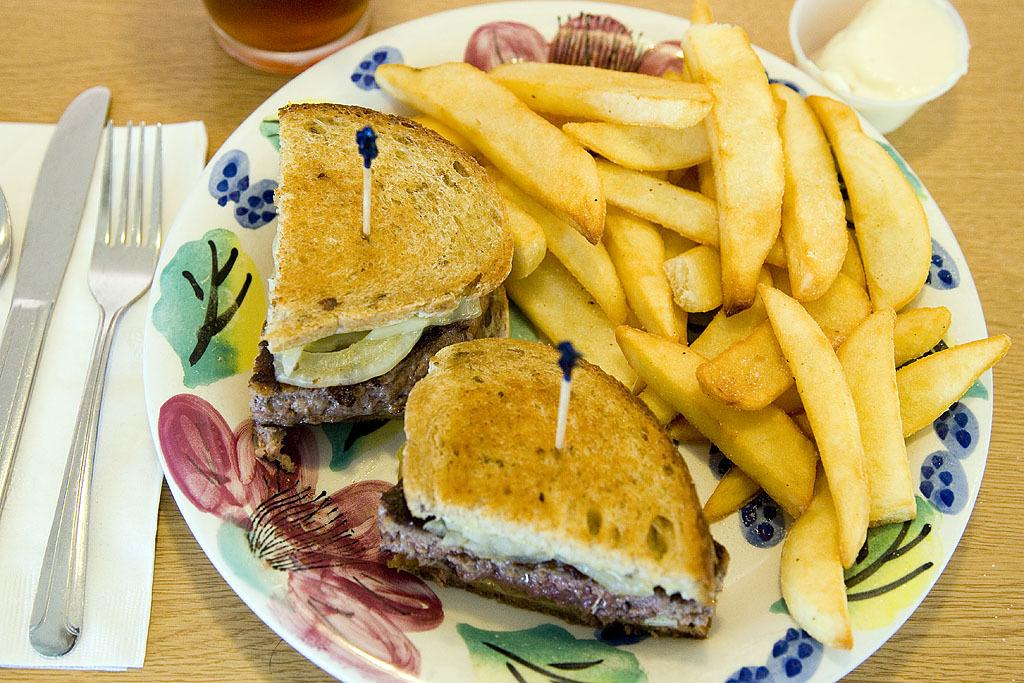What is on the plate that is visible in the image? There is a plate of food in the image. What item can be used for cleaning or wiping in the image? There is a tissue in the image for cleaning or wiping. What utensils are visible in the image? There is a fork, spoons, and a knife visible in the image. What is the surface on which the glasses are placed in the image? The glasses are placed on a wooden table in the image. Where is the giraffe sitting in the image? There is no giraffe present in the image. What is the father doing in the image? There is no father present in the image. What is the son eating in the image? There is no son present in the image. 